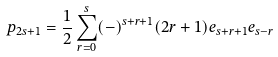Convert formula to latex. <formula><loc_0><loc_0><loc_500><loc_500>p _ { 2 s + 1 } = \frac { 1 } { 2 } \sum _ { r = 0 } ^ { s } ( - ) ^ { s + r + 1 } ( 2 r + 1 ) e _ { s + r + 1 } e _ { s - r }</formula> 